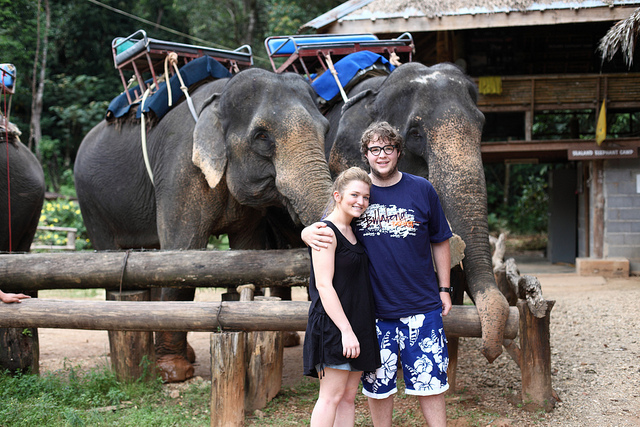How many elephants can be seen? 3 